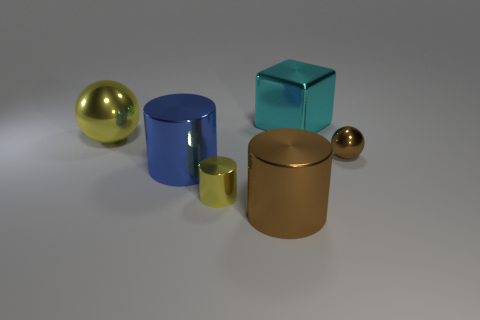Add 3 big brown cylinders. How many objects exist? 9 Subtract all cubes. How many objects are left? 5 Subtract all cyan shiny things. Subtract all yellow rubber spheres. How many objects are left? 5 Add 6 big brown cylinders. How many big brown cylinders are left? 7 Add 3 big yellow objects. How many big yellow objects exist? 4 Subtract 0 red cylinders. How many objects are left? 6 